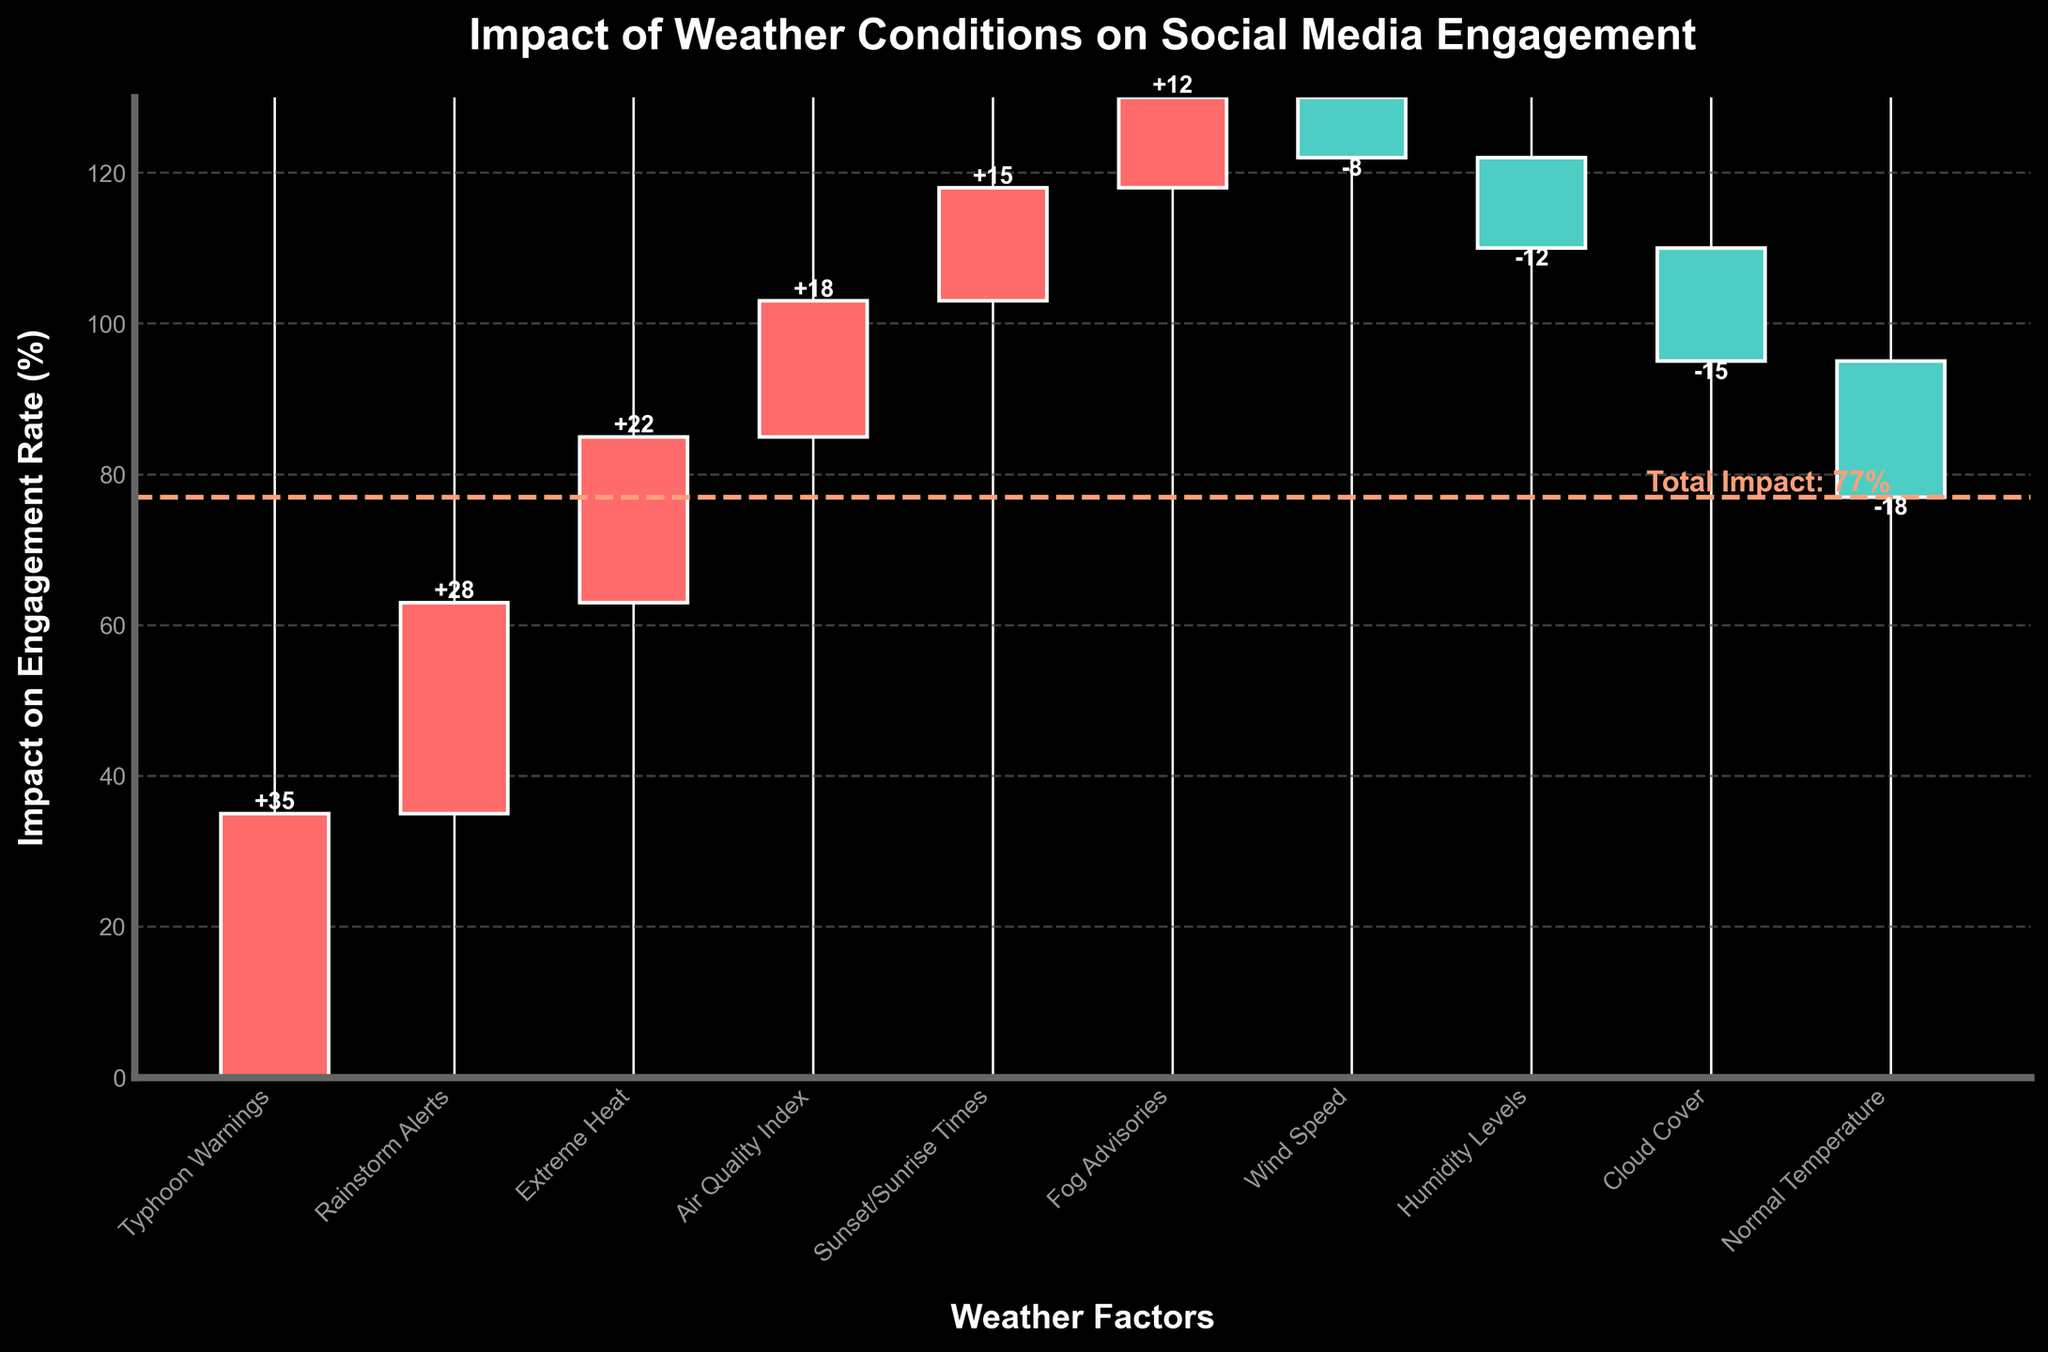Which weather factor has the highest positive impact on social media engagement rates? The highest positive impact can be found by looking at the factor with the tallest bar extending upwards. This factor is "Typhoon Warnings" with an impact of +35%.
Answer: Typhoon Warnings What is the total impact of all the weather conditions combined? To find the total impact, sum all the impact values from the figure: +35 + 28 + 22 + 18 + 15 + 12 - 8 - 12 - 15 - 18 = 77.
Answer: 77 How does the impact of Extreme Heat compare to that of Fog Advisories? Compare the impact values of Extreme Heat and Fog Advisories. Extreme Heat has an impact of +22% while Fog Advisories have +12%.
Answer: Extreme Heat has a greater impact Which weather factor has the largest negative impact on social media engagement rates? The largest negative impact can be determined by looking at the factor with the tallest bar extending downwards. This factor is "Normal Temperature" with an impact of -18%.
Answer: Normal Temperature How much more influential are Rainstorm Alerts compared to Wind Speed? Find the impact of Rainstorm Alerts and Wind Speed, then calculate the difference. Rainstorm Alerts have an impact of +28% and Wind Speed has -8%, so the difference is 28 - (-8) = 36.
Answer: 36 What is the cumulative effect on engagement after including the impact of the first three factors? Add the impacts of Typhoon Warnings, Rainstorm Alerts, and Extreme Heat: 35 + 28 + 22 = 85.
Answer: 85 Which factor is slightly less influential than Air Quality Index? Look for the factor immediately after Air Quality Index in the list. The Air Quality Index’s impact is +18%, and the next factor is "Sunset/Sunrise Times" with +15%.
Answer: Sunset/Sunrise Times What is the combined impact of all positive factors? Sum the impacts of factors with positive values: +35 + 28 + 22 + 18 + 15 + 12 = 130.
Answer: 130 What is the difference in impact between "Humidity Levels" and "Cloud Cover"? Use the impact values for Humidity Levels and Cloud Cover and find their difference: -12 - (-15) = 3.
Answer: 3 What can be inferred about the relationship between wind speed and social media engagement? Wind Speed has a negative impact of -8% on social media engagement, indicating that higher wind speed results in lower engagement.
Answer: Higher wind speed decreases engagement 